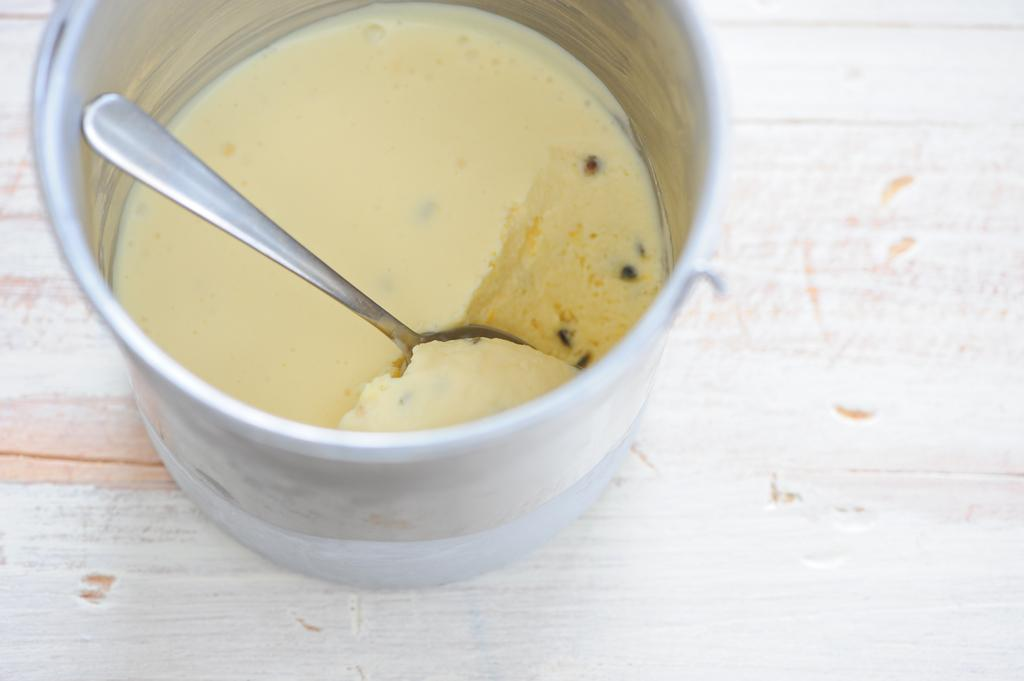What is the main subject of the image? The main subject of the image is an ice cream. What type of container is the ice cream in? The ice cream is in a steel vessel. What utensil is present in the image? There is a spoon in the image. What type of stocking is visible on the ice cream in the image? There is no stocking present on the ice cream in the image. How does the ice cream join the spoon in the image? The ice cream does not join the spoon in the image; it is simply placed in the steel vessel. 